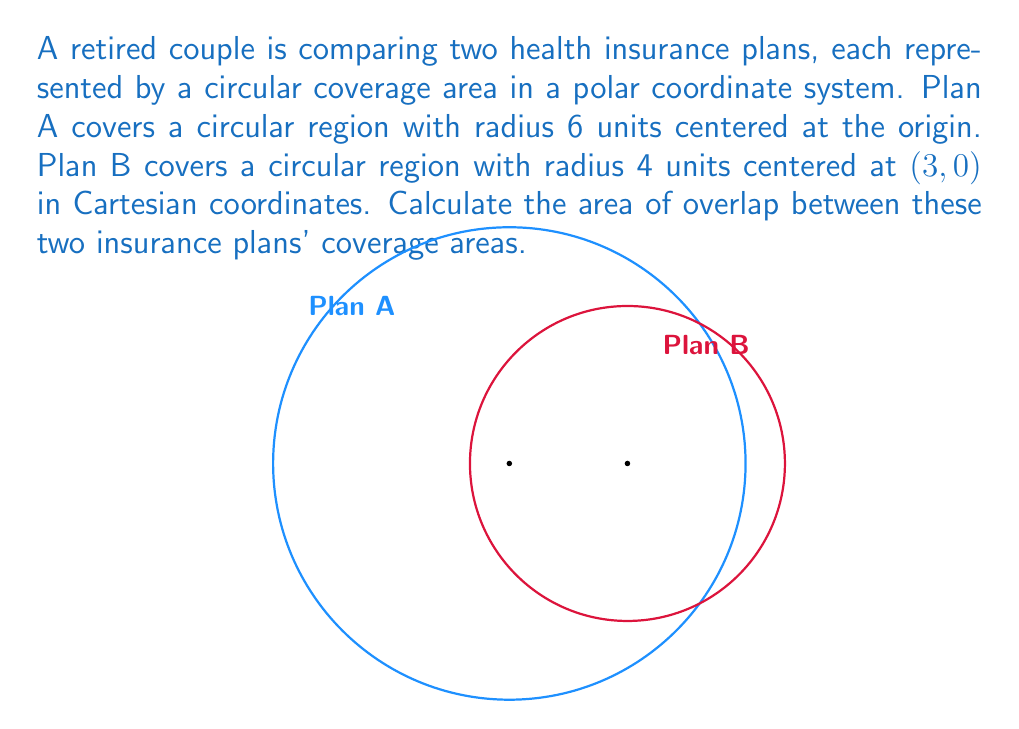Give your solution to this math problem. Let's approach this step-by-step:

1) First, we need to find the distance between the centers of the two circles. In Cartesian coordinates, this is simply 3 units (the x-coordinate of the center of Plan B).

2) Now, we can use the formula for the area of intersection of two circles:

   $$A = r_1^2 \arccos(\frac{d^2 + r_1^2 - r_2^2}{2dr_1}) + r_2^2 \arccos(\frac{d^2 + r_2^2 - r_1^2}{2dr_2}) - \frac{1}{2}\sqrt{(-d+r_1+r_2)(d+r_1-r_2)(d-r_1+r_2)(d+r_1+r_2)}$$

   Where $r_1$ and $r_2$ are the radii of the circles and $d$ is the distance between their centers.

3) In our case:
   $r_1 = 6$ (Plan A)
   $r_2 = 4$ (Plan B)
   $d = 3$

4) Substituting these values:

   $$A = 6^2 \arccos(\frac{3^2 + 6^2 - 4^2}{2 \cdot 3 \cdot 6}) + 4^2 \arccos(\frac{3^2 + 4^2 - 6^2}{2 \cdot 3 \cdot 4}) - \frac{1}{2}\sqrt{(-3+6+4)(3+6-4)(3-6+4)(3+6+4)}$$

5) Simplifying:

   $$A = 36 \arccos(\frac{29}{36}) + 16 \arccos(\frac{-11}{24}) - \frac{1}{2}\sqrt{7 \cdot 5 \cdot 1 \cdot 13}$$

6) Calculating:

   $$A \approx 36 \cdot 0.8762 + 16 \cdot 2.7037 - \frac{1}{2}\sqrt{455} \approx 31.5432 + 43.2592 - 10.6654 \approx 64.137$$

Therefore, the area of overlap is approximately 64.137 square units.
Answer: 64.137 square units 